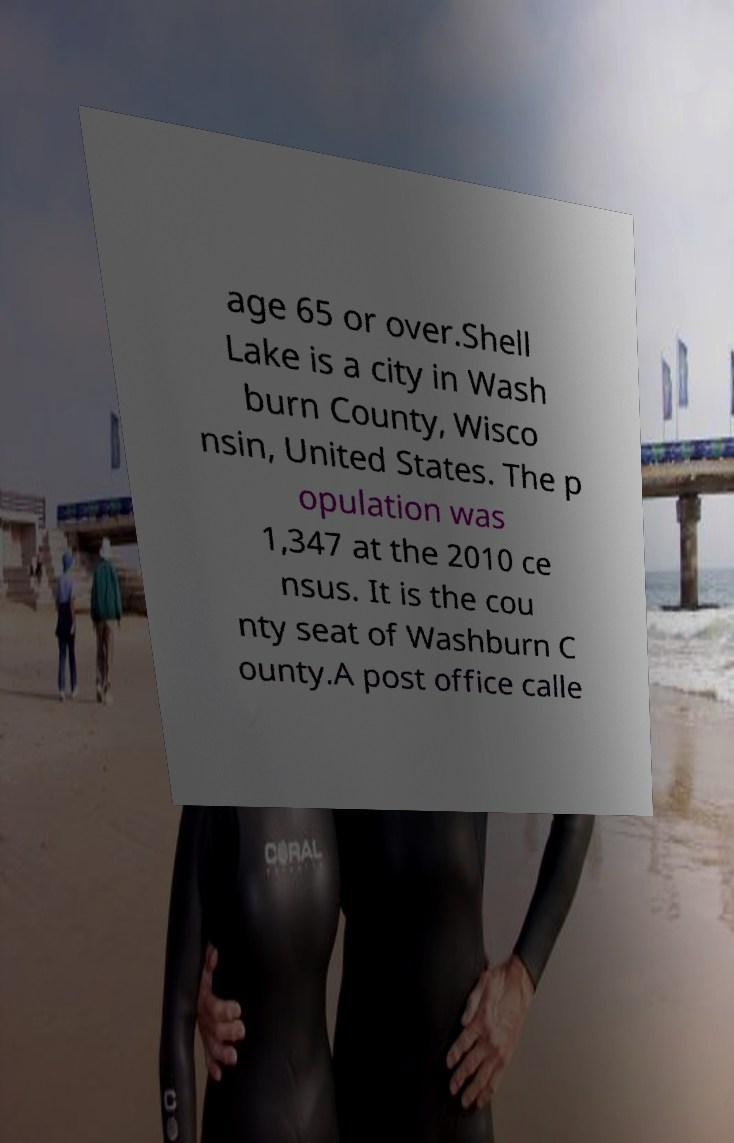Can you accurately transcribe the text from the provided image for me? age 65 or over.Shell Lake is a city in Wash burn County, Wisco nsin, United States. The p opulation was 1,347 at the 2010 ce nsus. It is the cou nty seat of Washburn C ounty.A post office calle 